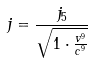<formula> <loc_0><loc_0><loc_500><loc_500>j = \frac { j _ { 5 } } { \sqrt { 1 \cdot \frac { v ^ { 9 } } { c ^ { 9 } } } }</formula> 